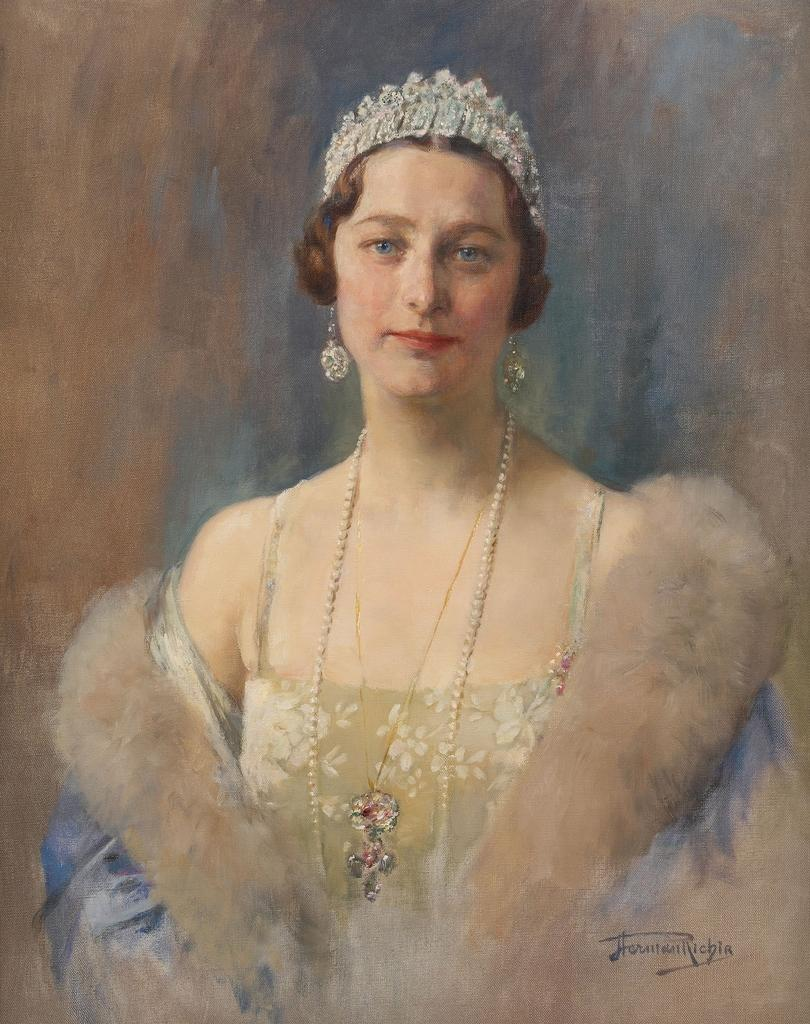What is depicted in the image? There is a painting of a woman in the image. What is the woman in the painting wearing? The woman in the painting is wearing a crown. Are there any additional details on the painting? Yes, there is writing on the painting. What type of drug is the cat using in the image? There is no cat or drug present in the image; it features a painting of a woman with a crown and writing. Is there a judge visible in the image? No, there is no judge present in the image; it features a painting of a woman with a crown and writing. 